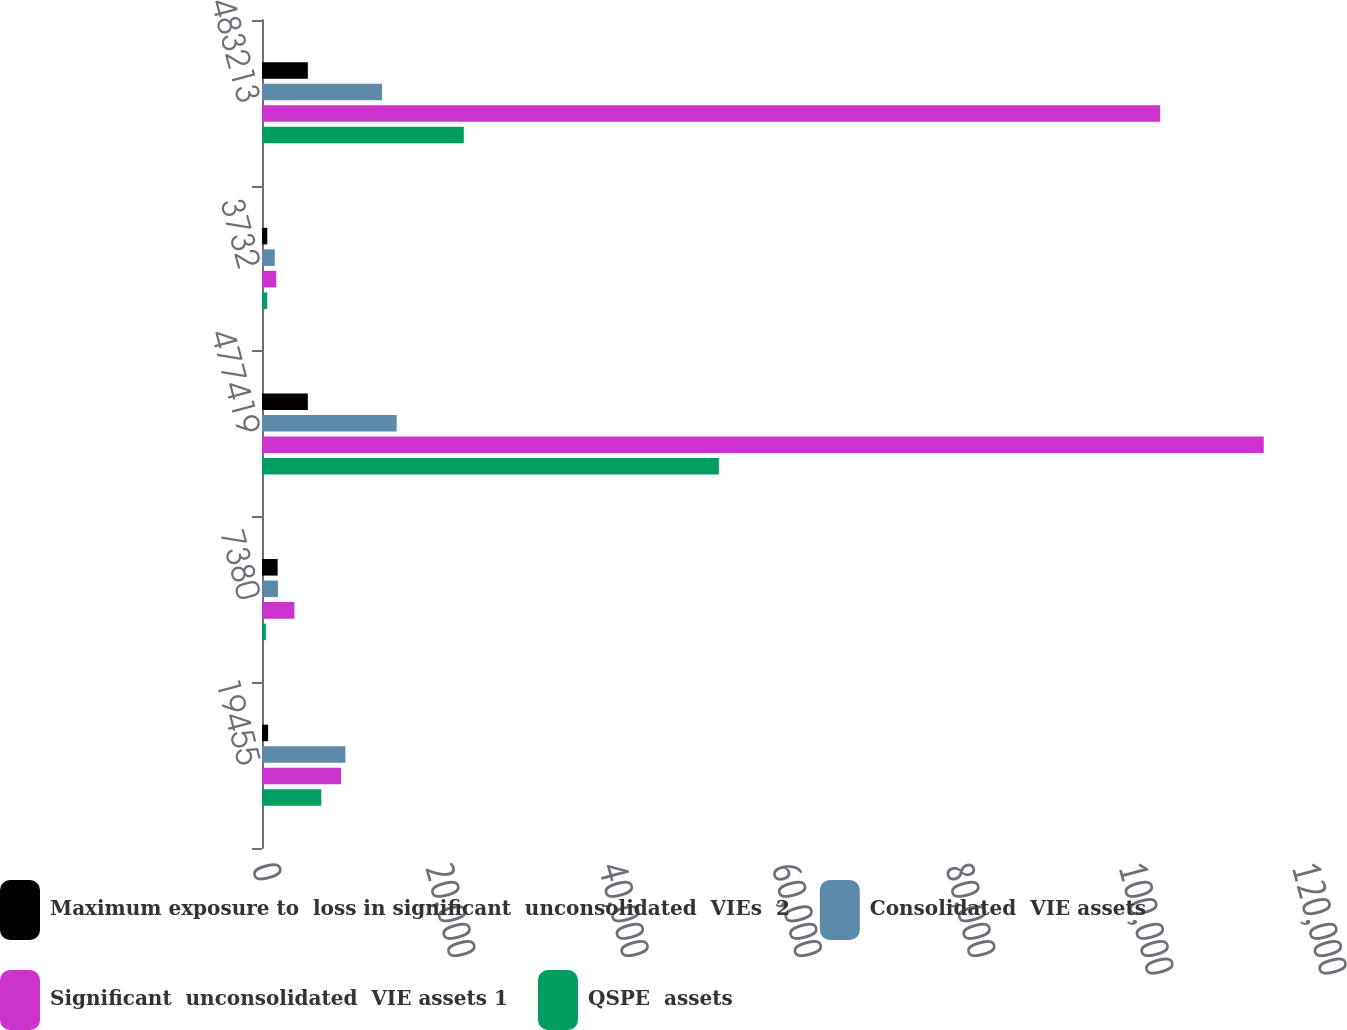Convert chart to OTSL. <chart><loc_0><loc_0><loc_500><loc_500><stacked_bar_chart><ecel><fcel>19455<fcel>7380<fcel>477419<fcel>3732<fcel>483213<nl><fcel>Maximum exposure to  loss in significant  unconsolidated  VIEs  2<fcel>705<fcel>1808<fcel>5287.5<fcel>610<fcel>5287.5<nl><fcel>Consolidated  VIE assets<fcel>9623<fcel>1838<fcel>15539<fcel>1472<fcel>13844<nl><fcel>Significant  unconsolidated  VIE assets 1<fcel>9127<fcel>3734<fcel>115585<fcel>1650<fcel>103638<nl><fcel>QSPE  assets<fcel>6841<fcel>446<fcel>52717<fcel>604<fcel>23283<nl></chart> 